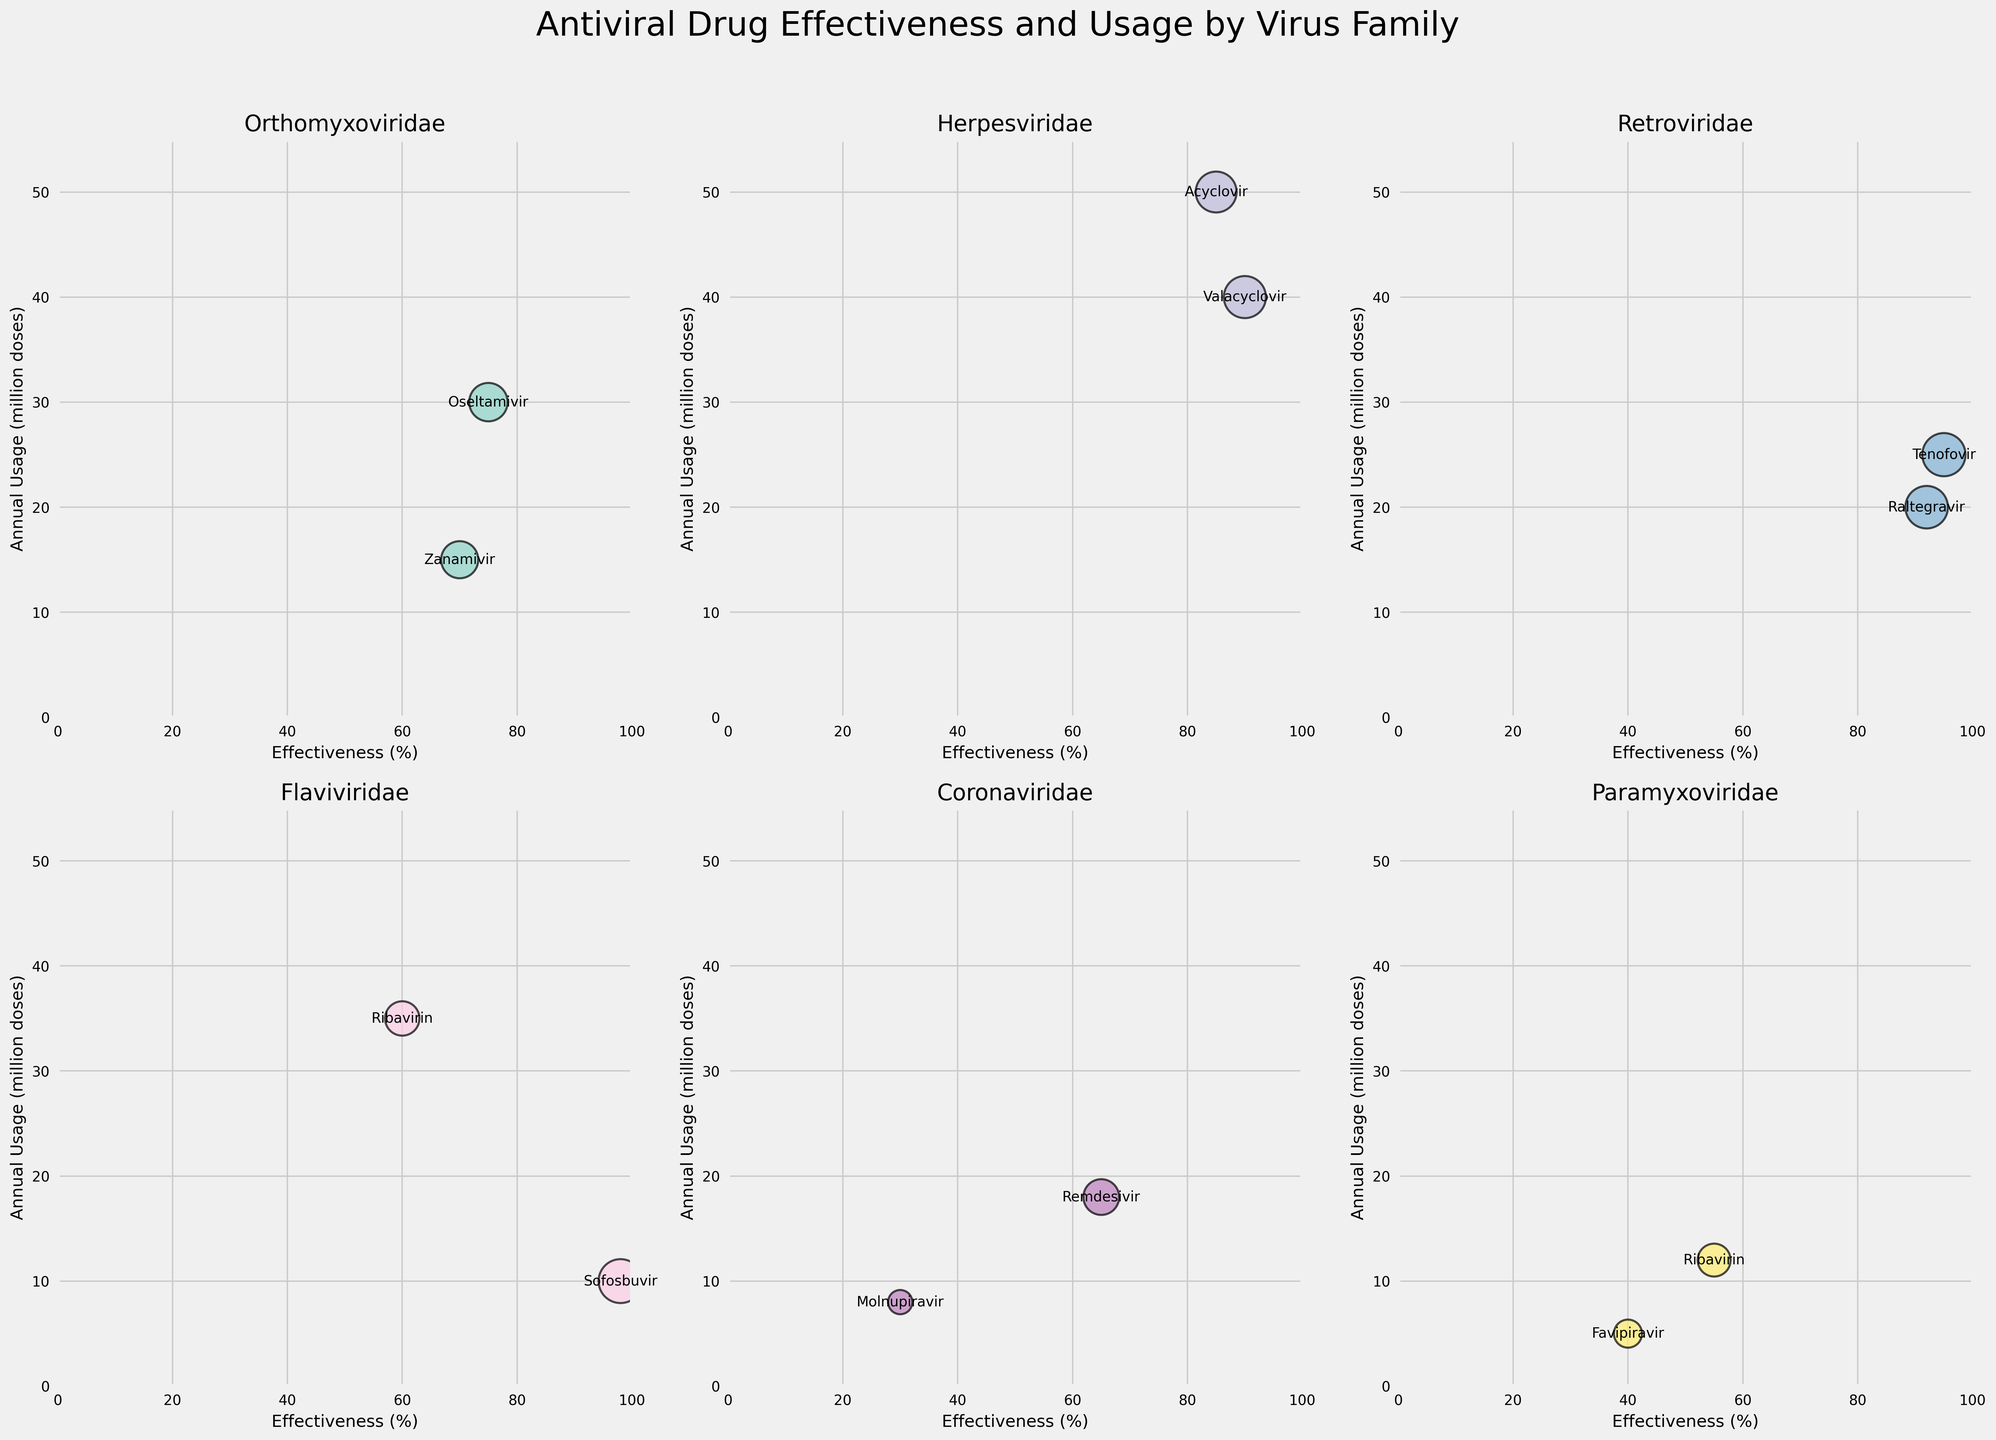What's the title of the figure? The title of the figure is displayed at the top. It summarizes the content of the figure.
Answer: Antiviral Drug Effectiveness and Usage by Virus Family What is the virus family with the highest annual usage for its most used drug? Look for the drug with the highest annual usage on the y-axis, then find the corresponding virus family.
Answer: Herpesviridae Which antiviral drug has the highest effectiveness? Compare the effectiveness percentages of all the drugs.
Answer: Sofosbuvir Which virus family has the drug with the lowest effectiveness, and what is that drug? Find the drug with the lowest effectiveness on the x-axis and identify its virus family.
Answer: Coronaviridae, Molnupiravir What is the average effectiveness of drugs in the Herpesviridae family? Sum the effectiveness percentages of Acyclovir and Valacyclovir and divide by the number of drugs. Calculation: (85 + 90) / 2 = 87.5
Answer: 87.5 Which drug has a greater effectiveness, Oseltamivir or Raltegravir? Compare the effectiveness percentages of Oseltamivir and Raltegravir.
Answer: Raltegravir Which virus family shows a wider range of annual usage for its drugs? Compare the ranges of annual usage (difference between the highest and lowest) within each family.
Answer: Orthomyxoviridae Between the drugs Remdesivir and Ribavirin which one has higher annual usage and by how much? Compare the annual usage of Remdesivir and Ribavirin and calculate the difference. Calculation: 35 - 18 = 17
Answer: Ribavirin, by 17 million doses What's the average annual usage of the drugs in the Paramyxoviridae family? Sum the annual usage of Ribavirin and Favipiravir and divide by the number of drugs. Calculation: (12 + 5) / 2 = 8.5
Answer: 8.5 